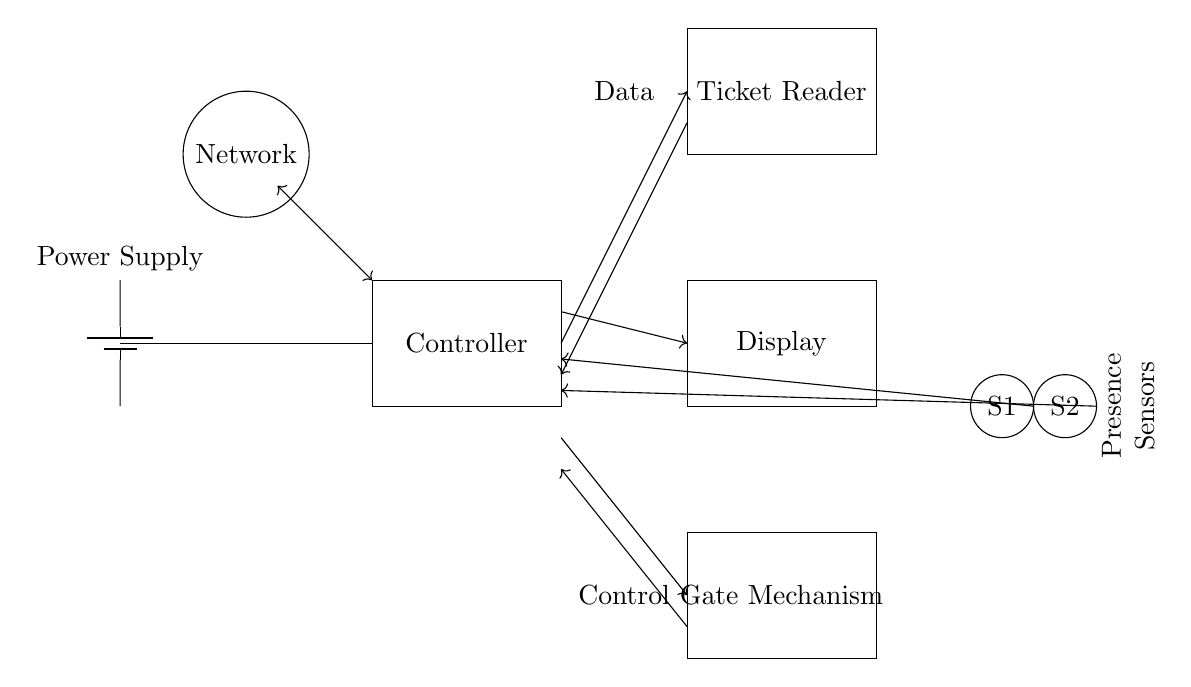What component connects to the power supply? The component connected to the power supply is the main controller, as indicated by the line from the power supply leading to the rectangle labeled 'Controller.'
Answer: Controller How many sensors are present in the circuit? There are two sensors shown in the diagram, labeled as S1 and S2, which are depicted as circles.
Answer: 2 What is the purpose of the display component? The display component is used to provide feedback or information to users, represented by the rectangle labeled 'Display.' It is connected to the controller, implying it receives and shows relevant data.
Answer: Feedback Which component does the ticket reader send data to? The ticket reader sends data to the controller, as indicated by the arrow pointing from the ticket reader to the controller.
Answer: Controller What is the function of the gate mechanism? The gate mechanism functions to control access, as it is connected to the controller and ticket reader, indicating it opens or closes based on the received information.
Answer: Control access What type of connection is used between the sensors and controller? The connection type used between the sensors and the controller is a direct connection, illustrated by arrows indicating data flow towards the controller from both sensors.
Answer: Direct connection What role does the network play in this circuit? The network allows for communication and data transfer, connecting to the controller and facilitating links with external systems, as shown by the circle labeled 'Network' linked to the controller.
Answer: Communication 